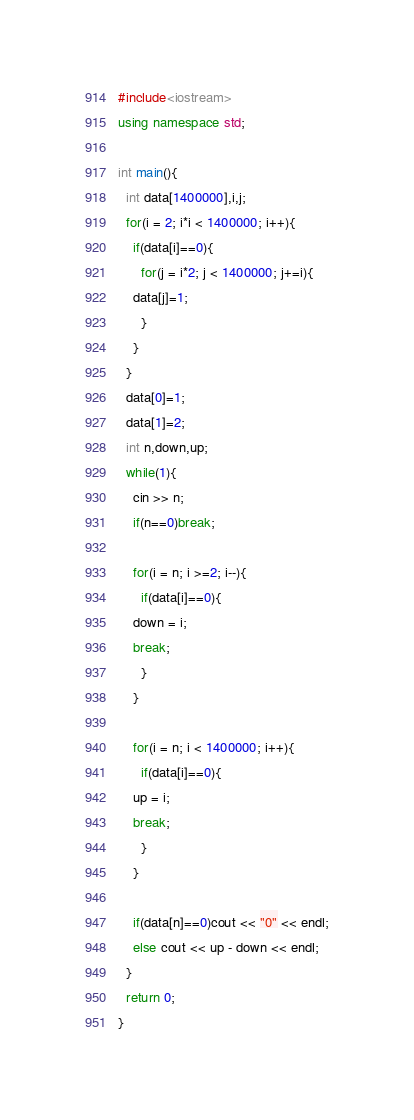<code> <loc_0><loc_0><loc_500><loc_500><_C++_>#include<iostream>
using namespace std;

int main(){
  int data[1400000],i,j;
  for(i = 2; i*i < 1400000; i++){
    if(data[i]==0){
      for(j = i*2; j < 1400000; j+=i){
	data[j]=1;
      }
    }
  }
  data[0]=1;
  data[1]=2;
  int n,down,up;
  while(1){
    cin >> n;
    if(n==0)break;
  
    for(i = n; i >=2; i--){
      if(data[i]==0){
	down = i;
	break;
      }
    }
    
    for(i = n; i < 1400000; i++){
      if(data[i]==0){
	up = i;
	break;
      }
    }
    
    if(data[n]==0)cout << "0" << endl;
    else cout << up - down << endl;
  }
  return 0;
}</code> 